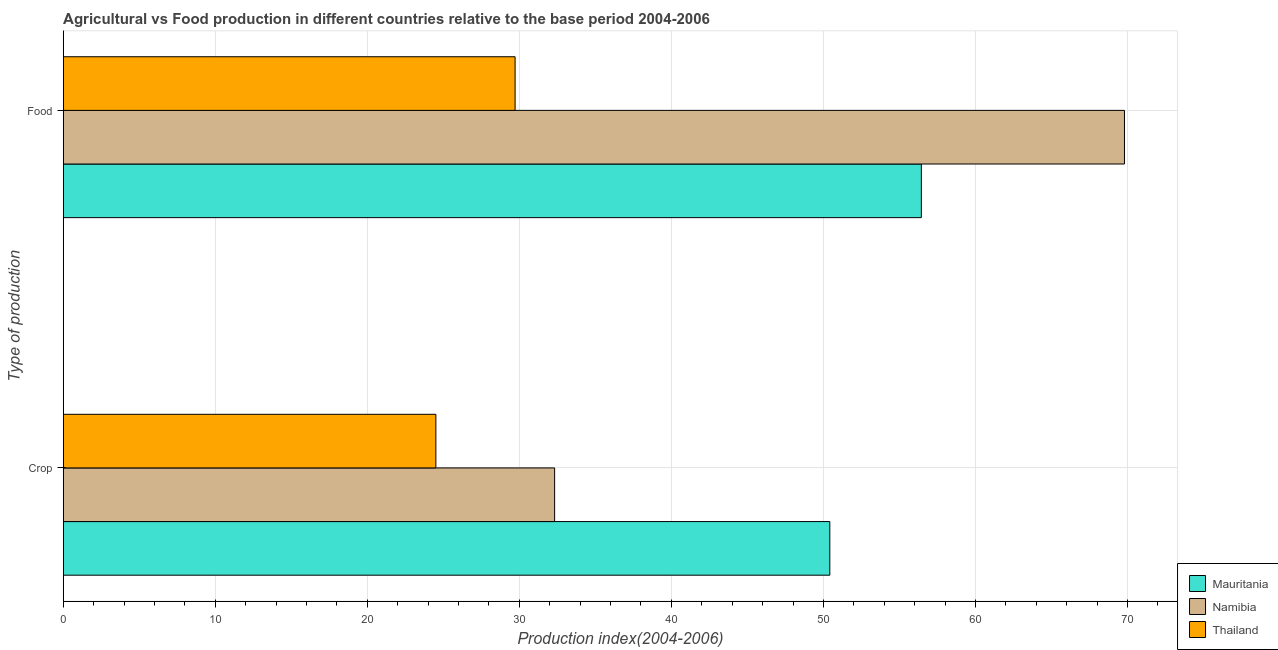What is the label of the 1st group of bars from the top?
Your answer should be compact. Food. What is the crop production index in Thailand?
Ensure brevity in your answer.  24.51. Across all countries, what is the maximum food production index?
Offer a terse response. 69.8. Across all countries, what is the minimum food production index?
Give a very brief answer. 29.72. In which country was the food production index maximum?
Your response must be concise. Namibia. In which country was the crop production index minimum?
Provide a succinct answer. Thailand. What is the total food production index in the graph?
Keep it short and to the point. 155.96. What is the difference between the crop production index in Mauritania and that in Thailand?
Your answer should be very brief. 25.91. What is the difference between the food production index in Mauritania and the crop production index in Namibia?
Your answer should be compact. 24.12. What is the average crop production index per country?
Offer a terse response. 35.75. What is the difference between the crop production index and food production index in Thailand?
Your answer should be very brief. -5.21. What is the ratio of the food production index in Namibia to that in Thailand?
Ensure brevity in your answer.  2.35. What does the 2nd bar from the top in Food represents?
Keep it short and to the point. Namibia. What does the 3rd bar from the bottom in Food represents?
Give a very brief answer. Thailand. What is the difference between two consecutive major ticks on the X-axis?
Offer a terse response. 10. Where does the legend appear in the graph?
Give a very brief answer. Bottom right. How many legend labels are there?
Provide a succinct answer. 3. What is the title of the graph?
Make the answer very short. Agricultural vs Food production in different countries relative to the base period 2004-2006. What is the label or title of the X-axis?
Keep it short and to the point. Production index(2004-2006). What is the label or title of the Y-axis?
Make the answer very short. Type of production. What is the Production index(2004-2006) of Mauritania in Crop?
Offer a terse response. 50.42. What is the Production index(2004-2006) in Namibia in Crop?
Your answer should be very brief. 32.32. What is the Production index(2004-2006) in Thailand in Crop?
Provide a short and direct response. 24.51. What is the Production index(2004-2006) in Mauritania in Food?
Offer a very short reply. 56.44. What is the Production index(2004-2006) in Namibia in Food?
Keep it short and to the point. 69.8. What is the Production index(2004-2006) of Thailand in Food?
Ensure brevity in your answer.  29.72. Across all Type of production, what is the maximum Production index(2004-2006) in Mauritania?
Provide a short and direct response. 56.44. Across all Type of production, what is the maximum Production index(2004-2006) of Namibia?
Offer a terse response. 69.8. Across all Type of production, what is the maximum Production index(2004-2006) in Thailand?
Your answer should be very brief. 29.72. Across all Type of production, what is the minimum Production index(2004-2006) of Mauritania?
Offer a terse response. 50.42. Across all Type of production, what is the minimum Production index(2004-2006) of Namibia?
Give a very brief answer. 32.32. Across all Type of production, what is the minimum Production index(2004-2006) in Thailand?
Keep it short and to the point. 24.51. What is the total Production index(2004-2006) in Mauritania in the graph?
Provide a short and direct response. 106.86. What is the total Production index(2004-2006) in Namibia in the graph?
Offer a very short reply. 102.12. What is the total Production index(2004-2006) of Thailand in the graph?
Your answer should be compact. 54.23. What is the difference between the Production index(2004-2006) of Mauritania in Crop and that in Food?
Offer a very short reply. -6.02. What is the difference between the Production index(2004-2006) of Namibia in Crop and that in Food?
Give a very brief answer. -37.48. What is the difference between the Production index(2004-2006) in Thailand in Crop and that in Food?
Offer a very short reply. -5.21. What is the difference between the Production index(2004-2006) in Mauritania in Crop and the Production index(2004-2006) in Namibia in Food?
Your answer should be very brief. -19.38. What is the difference between the Production index(2004-2006) in Mauritania in Crop and the Production index(2004-2006) in Thailand in Food?
Your response must be concise. 20.7. What is the difference between the Production index(2004-2006) in Namibia in Crop and the Production index(2004-2006) in Thailand in Food?
Give a very brief answer. 2.6. What is the average Production index(2004-2006) in Mauritania per Type of production?
Make the answer very short. 53.43. What is the average Production index(2004-2006) of Namibia per Type of production?
Keep it short and to the point. 51.06. What is the average Production index(2004-2006) in Thailand per Type of production?
Your answer should be very brief. 27.11. What is the difference between the Production index(2004-2006) in Mauritania and Production index(2004-2006) in Namibia in Crop?
Give a very brief answer. 18.1. What is the difference between the Production index(2004-2006) of Mauritania and Production index(2004-2006) of Thailand in Crop?
Your answer should be very brief. 25.91. What is the difference between the Production index(2004-2006) in Namibia and Production index(2004-2006) in Thailand in Crop?
Offer a terse response. 7.81. What is the difference between the Production index(2004-2006) in Mauritania and Production index(2004-2006) in Namibia in Food?
Keep it short and to the point. -13.36. What is the difference between the Production index(2004-2006) in Mauritania and Production index(2004-2006) in Thailand in Food?
Make the answer very short. 26.72. What is the difference between the Production index(2004-2006) in Namibia and Production index(2004-2006) in Thailand in Food?
Your answer should be very brief. 40.08. What is the ratio of the Production index(2004-2006) in Mauritania in Crop to that in Food?
Your answer should be compact. 0.89. What is the ratio of the Production index(2004-2006) of Namibia in Crop to that in Food?
Ensure brevity in your answer.  0.46. What is the ratio of the Production index(2004-2006) in Thailand in Crop to that in Food?
Your response must be concise. 0.82. What is the difference between the highest and the second highest Production index(2004-2006) of Mauritania?
Make the answer very short. 6.02. What is the difference between the highest and the second highest Production index(2004-2006) of Namibia?
Make the answer very short. 37.48. What is the difference between the highest and the second highest Production index(2004-2006) in Thailand?
Provide a short and direct response. 5.21. What is the difference between the highest and the lowest Production index(2004-2006) of Mauritania?
Provide a short and direct response. 6.02. What is the difference between the highest and the lowest Production index(2004-2006) of Namibia?
Provide a short and direct response. 37.48. What is the difference between the highest and the lowest Production index(2004-2006) in Thailand?
Give a very brief answer. 5.21. 